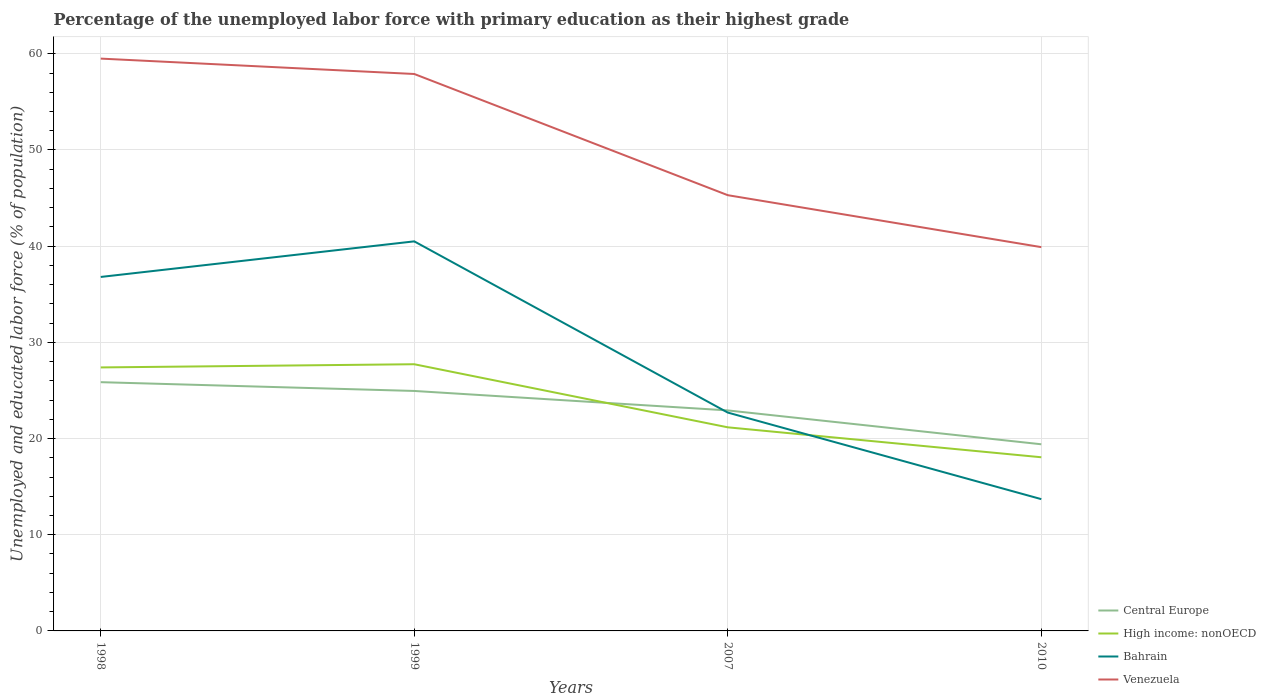How many different coloured lines are there?
Provide a short and direct response. 4. Is the number of lines equal to the number of legend labels?
Provide a short and direct response. Yes. Across all years, what is the maximum percentage of the unemployed labor force with primary education in High income: nonOECD?
Keep it short and to the point. 18.05. In which year was the percentage of the unemployed labor force with primary education in Venezuela maximum?
Your answer should be very brief. 2010. What is the total percentage of the unemployed labor force with primary education in High income: nonOECD in the graph?
Offer a terse response. 3.11. What is the difference between the highest and the second highest percentage of the unemployed labor force with primary education in Venezuela?
Your answer should be very brief. 19.6. How many years are there in the graph?
Provide a short and direct response. 4. How are the legend labels stacked?
Your answer should be very brief. Vertical. What is the title of the graph?
Your answer should be very brief. Percentage of the unemployed labor force with primary education as their highest grade. What is the label or title of the X-axis?
Offer a terse response. Years. What is the label or title of the Y-axis?
Offer a terse response. Unemployed and educated labor force (% of population). What is the Unemployed and educated labor force (% of population) in Central Europe in 1998?
Give a very brief answer. 25.86. What is the Unemployed and educated labor force (% of population) of High income: nonOECD in 1998?
Your answer should be very brief. 27.39. What is the Unemployed and educated labor force (% of population) in Bahrain in 1998?
Provide a succinct answer. 36.8. What is the Unemployed and educated labor force (% of population) of Venezuela in 1998?
Provide a succinct answer. 59.5. What is the Unemployed and educated labor force (% of population) in Central Europe in 1999?
Your answer should be very brief. 24.95. What is the Unemployed and educated labor force (% of population) in High income: nonOECD in 1999?
Make the answer very short. 27.72. What is the Unemployed and educated labor force (% of population) in Bahrain in 1999?
Offer a very short reply. 40.5. What is the Unemployed and educated labor force (% of population) of Venezuela in 1999?
Offer a terse response. 57.9. What is the Unemployed and educated labor force (% of population) in Central Europe in 2007?
Your answer should be very brief. 22.93. What is the Unemployed and educated labor force (% of population) in High income: nonOECD in 2007?
Ensure brevity in your answer.  21.17. What is the Unemployed and educated labor force (% of population) of Bahrain in 2007?
Provide a succinct answer. 22.7. What is the Unemployed and educated labor force (% of population) of Venezuela in 2007?
Make the answer very short. 45.3. What is the Unemployed and educated labor force (% of population) of Central Europe in 2010?
Make the answer very short. 19.41. What is the Unemployed and educated labor force (% of population) of High income: nonOECD in 2010?
Offer a terse response. 18.05. What is the Unemployed and educated labor force (% of population) of Bahrain in 2010?
Keep it short and to the point. 13.7. What is the Unemployed and educated labor force (% of population) of Venezuela in 2010?
Your answer should be compact. 39.9. Across all years, what is the maximum Unemployed and educated labor force (% of population) in Central Europe?
Your answer should be compact. 25.86. Across all years, what is the maximum Unemployed and educated labor force (% of population) of High income: nonOECD?
Offer a very short reply. 27.72. Across all years, what is the maximum Unemployed and educated labor force (% of population) of Bahrain?
Provide a succinct answer. 40.5. Across all years, what is the maximum Unemployed and educated labor force (% of population) of Venezuela?
Give a very brief answer. 59.5. Across all years, what is the minimum Unemployed and educated labor force (% of population) in Central Europe?
Provide a short and direct response. 19.41. Across all years, what is the minimum Unemployed and educated labor force (% of population) of High income: nonOECD?
Keep it short and to the point. 18.05. Across all years, what is the minimum Unemployed and educated labor force (% of population) in Bahrain?
Provide a short and direct response. 13.7. Across all years, what is the minimum Unemployed and educated labor force (% of population) of Venezuela?
Provide a succinct answer. 39.9. What is the total Unemployed and educated labor force (% of population) of Central Europe in the graph?
Offer a very short reply. 93.14. What is the total Unemployed and educated labor force (% of population) in High income: nonOECD in the graph?
Keep it short and to the point. 94.34. What is the total Unemployed and educated labor force (% of population) of Bahrain in the graph?
Offer a terse response. 113.7. What is the total Unemployed and educated labor force (% of population) of Venezuela in the graph?
Your answer should be very brief. 202.6. What is the difference between the Unemployed and educated labor force (% of population) of Central Europe in 1998 and that in 1999?
Ensure brevity in your answer.  0.91. What is the difference between the Unemployed and educated labor force (% of population) of High income: nonOECD in 1998 and that in 1999?
Your answer should be very brief. -0.33. What is the difference between the Unemployed and educated labor force (% of population) of Bahrain in 1998 and that in 1999?
Offer a very short reply. -3.7. What is the difference between the Unemployed and educated labor force (% of population) of Central Europe in 1998 and that in 2007?
Your answer should be very brief. 2.94. What is the difference between the Unemployed and educated labor force (% of population) in High income: nonOECD in 1998 and that in 2007?
Keep it short and to the point. 6.23. What is the difference between the Unemployed and educated labor force (% of population) in Venezuela in 1998 and that in 2007?
Provide a succinct answer. 14.2. What is the difference between the Unemployed and educated labor force (% of population) in Central Europe in 1998 and that in 2010?
Provide a short and direct response. 6.46. What is the difference between the Unemployed and educated labor force (% of population) of High income: nonOECD in 1998 and that in 2010?
Your answer should be very brief. 9.34. What is the difference between the Unemployed and educated labor force (% of population) of Bahrain in 1998 and that in 2010?
Provide a succinct answer. 23.1. What is the difference between the Unemployed and educated labor force (% of population) of Venezuela in 1998 and that in 2010?
Make the answer very short. 19.6. What is the difference between the Unemployed and educated labor force (% of population) of Central Europe in 1999 and that in 2007?
Your answer should be compact. 2.02. What is the difference between the Unemployed and educated labor force (% of population) of High income: nonOECD in 1999 and that in 2007?
Your answer should be compact. 6.56. What is the difference between the Unemployed and educated labor force (% of population) of Venezuela in 1999 and that in 2007?
Your response must be concise. 12.6. What is the difference between the Unemployed and educated labor force (% of population) of Central Europe in 1999 and that in 2010?
Make the answer very short. 5.54. What is the difference between the Unemployed and educated labor force (% of population) in High income: nonOECD in 1999 and that in 2010?
Your answer should be very brief. 9.67. What is the difference between the Unemployed and educated labor force (% of population) of Bahrain in 1999 and that in 2010?
Your answer should be compact. 26.8. What is the difference between the Unemployed and educated labor force (% of population) in Central Europe in 2007 and that in 2010?
Your answer should be very brief. 3.52. What is the difference between the Unemployed and educated labor force (% of population) of High income: nonOECD in 2007 and that in 2010?
Offer a very short reply. 3.11. What is the difference between the Unemployed and educated labor force (% of population) of Venezuela in 2007 and that in 2010?
Provide a short and direct response. 5.4. What is the difference between the Unemployed and educated labor force (% of population) of Central Europe in 1998 and the Unemployed and educated labor force (% of population) of High income: nonOECD in 1999?
Provide a succinct answer. -1.86. What is the difference between the Unemployed and educated labor force (% of population) in Central Europe in 1998 and the Unemployed and educated labor force (% of population) in Bahrain in 1999?
Offer a terse response. -14.64. What is the difference between the Unemployed and educated labor force (% of population) in Central Europe in 1998 and the Unemployed and educated labor force (% of population) in Venezuela in 1999?
Provide a succinct answer. -32.04. What is the difference between the Unemployed and educated labor force (% of population) of High income: nonOECD in 1998 and the Unemployed and educated labor force (% of population) of Bahrain in 1999?
Your answer should be compact. -13.11. What is the difference between the Unemployed and educated labor force (% of population) of High income: nonOECD in 1998 and the Unemployed and educated labor force (% of population) of Venezuela in 1999?
Offer a very short reply. -30.51. What is the difference between the Unemployed and educated labor force (% of population) in Bahrain in 1998 and the Unemployed and educated labor force (% of population) in Venezuela in 1999?
Your response must be concise. -21.1. What is the difference between the Unemployed and educated labor force (% of population) in Central Europe in 1998 and the Unemployed and educated labor force (% of population) in High income: nonOECD in 2007?
Your answer should be very brief. 4.69. What is the difference between the Unemployed and educated labor force (% of population) of Central Europe in 1998 and the Unemployed and educated labor force (% of population) of Bahrain in 2007?
Ensure brevity in your answer.  3.16. What is the difference between the Unemployed and educated labor force (% of population) in Central Europe in 1998 and the Unemployed and educated labor force (% of population) in Venezuela in 2007?
Ensure brevity in your answer.  -19.44. What is the difference between the Unemployed and educated labor force (% of population) of High income: nonOECD in 1998 and the Unemployed and educated labor force (% of population) of Bahrain in 2007?
Ensure brevity in your answer.  4.69. What is the difference between the Unemployed and educated labor force (% of population) in High income: nonOECD in 1998 and the Unemployed and educated labor force (% of population) in Venezuela in 2007?
Your answer should be very brief. -17.91. What is the difference between the Unemployed and educated labor force (% of population) of Central Europe in 1998 and the Unemployed and educated labor force (% of population) of High income: nonOECD in 2010?
Offer a terse response. 7.81. What is the difference between the Unemployed and educated labor force (% of population) in Central Europe in 1998 and the Unemployed and educated labor force (% of population) in Bahrain in 2010?
Your answer should be compact. 12.16. What is the difference between the Unemployed and educated labor force (% of population) of Central Europe in 1998 and the Unemployed and educated labor force (% of population) of Venezuela in 2010?
Keep it short and to the point. -14.04. What is the difference between the Unemployed and educated labor force (% of population) in High income: nonOECD in 1998 and the Unemployed and educated labor force (% of population) in Bahrain in 2010?
Offer a terse response. 13.69. What is the difference between the Unemployed and educated labor force (% of population) of High income: nonOECD in 1998 and the Unemployed and educated labor force (% of population) of Venezuela in 2010?
Offer a terse response. -12.51. What is the difference between the Unemployed and educated labor force (% of population) in Bahrain in 1998 and the Unemployed and educated labor force (% of population) in Venezuela in 2010?
Offer a very short reply. -3.1. What is the difference between the Unemployed and educated labor force (% of population) in Central Europe in 1999 and the Unemployed and educated labor force (% of population) in High income: nonOECD in 2007?
Offer a terse response. 3.78. What is the difference between the Unemployed and educated labor force (% of population) in Central Europe in 1999 and the Unemployed and educated labor force (% of population) in Bahrain in 2007?
Offer a very short reply. 2.25. What is the difference between the Unemployed and educated labor force (% of population) in Central Europe in 1999 and the Unemployed and educated labor force (% of population) in Venezuela in 2007?
Your answer should be very brief. -20.35. What is the difference between the Unemployed and educated labor force (% of population) of High income: nonOECD in 1999 and the Unemployed and educated labor force (% of population) of Bahrain in 2007?
Offer a terse response. 5.02. What is the difference between the Unemployed and educated labor force (% of population) in High income: nonOECD in 1999 and the Unemployed and educated labor force (% of population) in Venezuela in 2007?
Your response must be concise. -17.58. What is the difference between the Unemployed and educated labor force (% of population) in Central Europe in 1999 and the Unemployed and educated labor force (% of population) in High income: nonOECD in 2010?
Offer a very short reply. 6.89. What is the difference between the Unemployed and educated labor force (% of population) in Central Europe in 1999 and the Unemployed and educated labor force (% of population) in Bahrain in 2010?
Give a very brief answer. 11.25. What is the difference between the Unemployed and educated labor force (% of population) in Central Europe in 1999 and the Unemployed and educated labor force (% of population) in Venezuela in 2010?
Make the answer very short. -14.95. What is the difference between the Unemployed and educated labor force (% of population) of High income: nonOECD in 1999 and the Unemployed and educated labor force (% of population) of Bahrain in 2010?
Your answer should be very brief. 14.02. What is the difference between the Unemployed and educated labor force (% of population) of High income: nonOECD in 1999 and the Unemployed and educated labor force (% of population) of Venezuela in 2010?
Offer a very short reply. -12.18. What is the difference between the Unemployed and educated labor force (% of population) of Bahrain in 1999 and the Unemployed and educated labor force (% of population) of Venezuela in 2010?
Your answer should be very brief. 0.6. What is the difference between the Unemployed and educated labor force (% of population) of Central Europe in 2007 and the Unemployed and educated labor force (% of population) of High income: nonOECD in 2010?
Offer a terse response. 4.87. What is the difference between the Unemployed and educated labor force (% of population) in Central Europe in 2007 and the Unemployed and educated labor force (% of population) in Bahrain in 2010?
Make the answer very short. 9.23. What is the difference between the Unemployed and educated labor force (% of population) of Central Europe in 2007 and the Unemployed and educated labor force (% of population) of Venezuela in 2010?
Ensure brevity in your answer.  -16.97. What is the difference between the Unemployed and educated labor force (% of population) of High income: nonOECD in 2007 and the Unemployed and educated labor force (% of population) of Bahrain in 2010?
Your response must be concise. 7.47. What is the difference between the Unemployed and educated labor force (% of population) of High income: nonOECD in 2007 and the Unemployed and educated labor force (% of population) of Venezuela in 2010?
Offer a terse response. -18.73. What is the difference between the Unemployed and educated labor force (% of population) in Bahrain in 2007 and the Unemployed and educated labor force (% of population) in Venezuela in 2010?
Offer a very short reply. -17.2. What is the average Unemployed and educated labor force (% of population) in Central Europe per year?
Make the answer very short. 23.28. What is the average Unemployed and educated labor force (% of population) of High income: nonOECD per year?
Provide a short and direct response. 23.59. What is the average Unemployed and educated labor force (% of population) in Bahrain per year?
Your answer should be compact. 28.43. What is the average Unemployed and educated labor force (% of population) in Venezuela per year?
Provide a short and direct response. 50.65. In the year 1998, what is the difference between the Unemployed and educated labor force (% of population) of Central Europe and Unemployed and educated labor force (% of population) of High income: nonOECD?
Provide a short and direct response. -1.53. In the year 1998, what is the difference between the Unemployed and educated labor force (% of population) of Central Europe and Unemployed and educated labor force (% of population) of Bahrain?
Make the answer very short. -10.94. In the year 1998, what is the difference between the Unemployed and educated labor force (% of population) in Central Europe and Unemployed and educated labor force (% of population) in Venezuela?
Provide a succinct answer. -33.64. In the year 1998, what is the difference between the Unemployed and educated labor force (% of population) in High income: nonOECD and Unemployed and educated labor force (% of population) in Bahrain?
Keep it short and to the point. -9.41. In the year 1998, what is the difference between the Unemployed and educated labor force (% of population) in High income: nonOECD and Unemployed and educated labor force (% of population) in Venezuela?
Ensure brevity in your answer.  -32.11. In the year 1998, what is the difference between the Unemployed and educated labor force (% of population) in Bahrain and Unemployed and educated labor force (% of population) in Venezuela?
Provide a short and direct response. -22.7. In the year 1999, what is the difference between the Unemployed and educated labor force (% of population) in Central Europe and Unemployed and educated labor force (% of population) in High income: nonOECD?
Ensure brevity in your answer.  -2.78. In the year 1999, what is the difference between the Unemployed and educated labor force (% of population) in Central Europe and Unemployed and educated labor force (% of population) in Bahrain?
Your answer should be very brief. -15.55. In the year 1999, what is the difference between the Unemployed and educated labor force (% of population) of Central Europe and Unemployed and educated labor force (% of population) of Venezuela?
Offer a very short reply. -32.95. In the year 1999, what is the difference between the Unemployed and educated labor force (% of population) of High income: nonOECD and Unemployed and educated labor force (% of population) of Bahrain?
Make the answer very short. -12.78. In the year 1999, what is the difference between the Unemployed and educated labor force (% of population) in High income: nonOECD and Unemployed and educated labor force (% of population) in Venezuela?
Provide a succinct answer. -30.18. In the year 1999, what is the difference between the Unemployed and educated labor force (% of population) in Bahrain and Unemployed and educated labor force (% of population) in Venezuela?
Give a very brief answer. -17.4. In the year 2007, what is the difference between the Unemployed and educated labor force (% of population) in Central Europe and Unemployed and educated labor force (% of population) in High income: nonOECD?
Your response must be concise. 1.76. In the year 2007, what is the difference between the Unemployed and educated labor force (% of population) in Central Europe and Unemployed and educated labor force (% of population) in Bahrain?
Your answer should be compact. 0.23. In the year 2007, what is the difference between the Unemployed and educated labor force (% of population) of Central Europe and Unemployed and educated labor force (% of population) of Venezuela?
Give a very brief answer. -22.37. In the year 2007, what is the difference between the Unemployed and educated labor force (% of population) in High income: nonOECD and Unemployed and educated labor force (% of population) in Bahrain?
Provide a short and direct response. -1.53. In the year 2007, what is the difference between the Unemployed and educated labor force (% of population) in High income: nonOECD and Unemployed and educated labor force (% of population) in Venezuela?
Provide a succinct answer. -24.13. In the year 2007, what is the difference between the Unemployed and educated labor force (% of population) of Bahrain and Unemployed and educated labor force (% of population) of Venezuela?
Your response must be concise. -22.6. In the year 2010, what is the difference between the Unemployed and educated labor force (% of population) of Central Europe and Unemployed and educated labor force (% of population) of High income: nonOECD?
Provide a short and direct response. 1.35. In the year 2010, what is the difference between the Unemployed and educated labor force (% of population) of Central Europe and Unemployed and educated labor force (% of population) of Bahrain?
Provide a succinct answer. 5.71. In the year 2010, what is the difference between the Unemployed and educated labor force (% of population) of Central Europe and Unemployed and educated labor force (% of population) of Venezuela?
Offer a very short reply. -20.5. In the year 2010, what is the difference between the Unemployed and educated labor force (% of population) of High income: nonOECD and Unemployed and educated labor force (% of population) of Bahrain?
Make the answer very short. 4.35. In the year 2010, what is the difference between the Unemployed and educated labor force (% of population) in High income: nonOECD and Unemployed and educated labor force (% of population) in Venezuela?
Your answer should be very brief. -21.85. In the year 2010, what is the difference between the Unemployed and educated labor force (% of population) of Bahrain and Unemployed and educated labor force (% of population) of Venezuela?
Make the answer very short. -26.2. What is the ratio of the Unemployed and educated labor force (% of population) in Central Europe in 1998 to that in 1999?
Provide a succinct answer. 1.04. What is the ratio of the Unemployed and educated labor force (% of population) of High income: nonOECD in 1998 to that in 1999?
Make the answer very short. 0.99. What is the ratio of the Unemployed and educated labor force (% of population) in Bahrain in 1998 to that in 1999?
Your answer should be compact. 0.91. What is the ratio of the Unemployed and educated labor force (% of population) in Venezuela in 1998 to that in 1999?
Ensure brevity in your answer.  1.03. What is the ratio of the Unemployed and educated labor force (% of population) of Central Europe in 1998 to that in 2007?
Provide a succinct answer. 1.13. What is the ratio of the Unemployed and educated labor force (% of population) in High income: nonOECD in 1998 to that in 2007?
Offer a terse response. 1.29. What is the ratio of the Unemployed and educated labor force (% of population) of Bahrain in 1998 to that in 2007?
Provide a short and direct response. 1.62. What is the ratio of the Unemployed and educated labor force (% of population) in Venezuela in 1998 to that in 2007?
Your answer should be compact. 1.31. What is the ratio of the Unemployed and educated labor force (% of population) of Central Europe in 1998 to that in 2010?
Provide a short and direct response. 1.33. What is the ratio of the Unemployed and educated labor force (% of population) in High income: nonOECD in 1998 to that in 2010?
Offer a very short reply. 1.52. What is the ratio of the Unemployed and educated labor force (% of population) in Bahrain in 1998 to that in 2010?
Provide a succinct answer. 2.69. What is the ratio of the Unemployed and educated labor force (% of population) in Venezuela in 1998 to that in 2010?
Make the answer very short. 1.49. What is the ratio of the Unemployed and educated labor force (% of population) of Central Europe in 1999 to that in 2007?
Keep it short and to the point. 1.09. What is the ratio of the Unemployed and educated labor force (% of population) in High income: nonOECD in 1999 to that in 2007?
Ensure brevity in your answer.  1.31. What is the ratio of the Unemployed and educated labor force (% of population) of Bahrain in 1999 to that in 2007?
Your answer should be very brief. 1.78. What is the ratio of the Unemployed and educated labor force (% of population) in Venezuela in 1999 to that in 2007?
Offer a terse response. 1.28. What is the ratio of the Unemployed and educated labor force (% of population) in Central Europe in 1999 to that in 2010?
Keep it short and to the point. 1.29. What is the ratio of the Unemployed and educated labor force (% of population) of High income: nonOECD in 1999 to that in 2010?
Your response must be concise. 1.54. What is the ratio of the Unemployed and educated labor force (% of population) of Bahrain in 1999 to that in 2010?
Keep it short and to the point. 2.96. What is the ratio of the Unemployed and educated labor force (% of population) of Venezuela in 1999 to that in 2010?
Ensure brevity in your answer.  1.45. What is the ratio of the Unemployed and educated labor force (% of population) in Central Europe in 2007 to that in 2010?
Give a very brief answer. 1.18. What is the ratio of the Unemployed and educated labor force (% of population) of High income: nonOECD in 2007 to that in 2010?
Ensure brevity in your answer.  1.17. What is the ratio of the Unemployed and educated labor force (% of population) of Bahrain in 2007 to that in 2010?
Your answer should be compact. 1.66. What is the ratio of the Unemployed and educated labor force (% of population) of Venezuela in 2007 to that in 2010?
Your answer should be very brief. 1.14. What is the difference between the highest and the second highest Unemployed and educated labor force (% of population) in Central Europe?
Make the answer very short. 0.91. What is the difference between the highest and the second highest Unemployed and educated labor force (% of population) of High income: nonOECD?
Offer a very short reply. 0.33. What is the difference between the highest and the lowest Unemployed and educated labor force (% of population) of Central Europe?
Ensure brevity in your answer.  6.46. What is the difference between the highest and the lowest Unemployed and educated labor force (% of population) of High income: nonOECD?
Provide a short and direct response. 9.67. What is the difference between the highest and the lowest Unemployed and educated labor force (% of population) of Bahrain?
Ensure brevity in your answer.  26.8. What is the difference between the highest and the lowest Unemployed and educated labor force (% of population) of Venezuela?
Your answer should be compact. 19.6. 